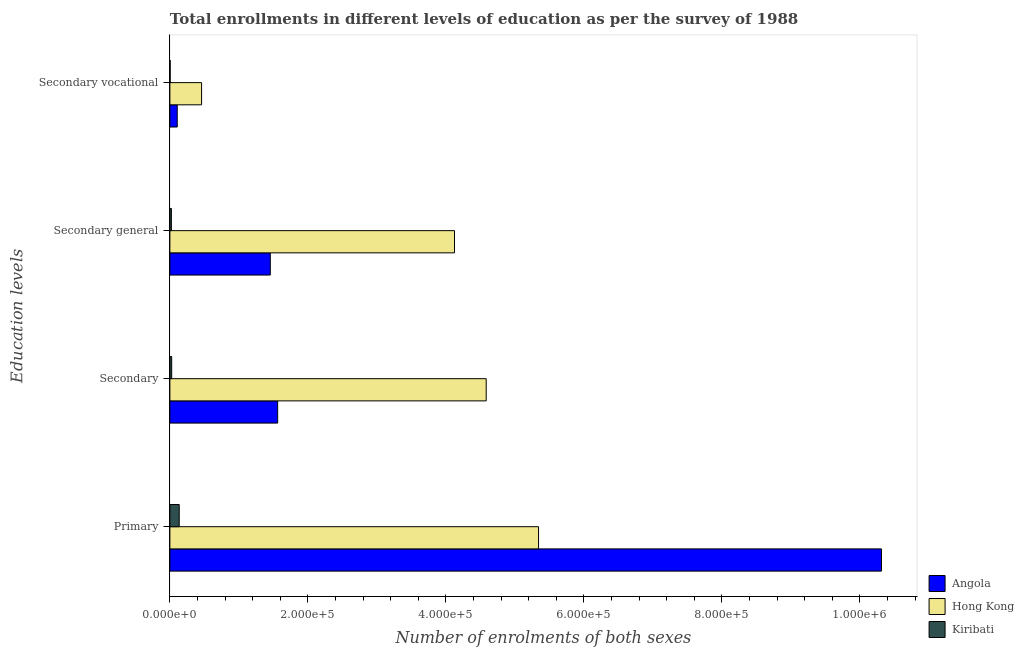How many groups of bars are there?
Offer a very short reply. 4. Are the number of bars on each tick of the Y-axis equal?
Offer a very short reply. Yes. How many bars are there on the 4th tick from the top?
Ensure brevity in your answer.  3. How many bars are there on the 4th tick from the bottom?
Your response must be concise. 3. What is the label of the 2nd group of bars from the top?
Ensure brevity in your answer.  Secondary general. What is the number of enrolments in primary education in Angola?
Ensure brevity in your answer.  1.03e+06. Across all countries, what is the maximum number of enrolments in secondary general education?
Make the answer very short. 4.13e+05. Across all countries, what is the minimum number of enrolments in secondary general education?
Offer a terse response. 2191. In which country was the number of enrolments in secondary general education maximum?
Your response must be concise. Hong Kong. In which country was the number of enrolments in secondary vocational education minimum?
Ensure brevity in your answer.  Kiribati. What is the total number of enrolments in secondary education in the graph?
Provide a succinct answer. 6.17e+05. What is the difference between the number of enrolments in secondary vocational education in Hong Kong and that in Kiribati?
Provide a short and direct response. 4.55e+04. What is the difference between the number of enrolments in primary education in Hong Kong and the number of enrolments in secondary general education in Angola?
Provide a succinct answer. 3.89e+05. What is the average number of enrolments in secondary general education per country?
Ensure brevity in your answer.  1.87e+05. What is the difference between the number of enrolments in secondary education and number of enrolments in secondary vocational education in Hong Kong?
Ensure brevity in your answer.  4.13e+05. What is the ratio of the number of enrolments in secondary vocational education in Kiribati to that in Angola?
Offer a terse response. 0.04. What is the difference between the highest and the second highest number of enrolments in primary education?
Your answer should be very brief. 4.97e+05. What is the difference between the highest and the lowest number of enrolments in secondary education?
Offer a terse response. 4.56e+05. In how many countries, is the number of enrolments in secondary general education greater than the average number of enrolments in secondary general education taken over all countries?
Ensure brevity in your answer.  1. Is the sum of the number of enrolments in secondary general education in Angola and Kiribati greater than the maximum number of enrolments in secondary vocational education across all countries?
Offer a terse response. Yes. What does the 1st bar from the top in Primary represents?
Provide a succinct answer. Kiribati. What does the 3rd bar from the bottom in Secondary vocational represents?
Your answer should be very brief. Kiribati. Is it the case that in every country, the sum of the number of enrolments in primary education and number of enrolments in secondary education is greater than the number of enrolments in secondary general education?
Your response must be concise. Yes. How many countries are there in the graph?
Provide a short and direct response. 3. What is the difference between two consecutive major ticks on the X-axis?
Provide a succinct answer. 2.00e+05. Does the graph contain any zero values?
Offer a terse response. No. Does the graph contain grids?
Ensure brevity in your answer.  No. Where does the legend appear in the graph?
Your answer should be compact. Bottom right. How many legend labels are there?
Keep it short and to the point. 3. How are the legend labels stacked?
Keep it short and to the point. Vertical. What is the title of the graph?
Provide a succinct answer. Total enrollments in different levels of education as per the survey of 1988. Does "Sudan" appear as one of the legend labels in the graph?
Provide a succinct answer. No. What is the label or title of the X-axis?
Provide a short and direct response. Number of enrolments of both sexes. What is the label or title of the Y-axis?
Offer a very short reply. Education levels. What is the Number of enrolments of both sexes in Angola in Primary?
Make the answer very short. 1.03e+06. What is the Number of enrolments of both sexes in Hong Kong in Primary?
Offer a very short reply. 5.34e+05. What is the Number of enrolments of both sexes in Kiribati in Primary?
Offer a terse response. 1.36e+04. What is the Number of enrolments of both sexes in Angola in Secondary?
Your answer should be very brief. 1.56e+05. What is the Number of enrolments of both sexes of Hong Kong in Secondary?
Provide a short and direct response. 4.58e+05. What is the Number of enrolments of both sexes of Kiribati in Secondary?
Offer a terse response. 2601. What is the Number of enrolments of both sexes in Angola in Secondary general?
Provide a short and direct response. 1.46e+05. What is the Number of enrolments of both sexes in Hong Kong in Secondary general?
Your answer should be very brief. 4.13e+05. What is the Number of enrolments of both sexes in Kiribati in Secondary general?
Your answer should be very brief. 2191. What is the Number of enrolments of both sexes of Angola in Secondary vocational?
Provide a short and direct response. 1.07e+04. What is the Number of enrolments of both sexes in Hong Kong in Secondary vocational?
Keep it short and to the point. 4.59e+04. What is the Number of enrolments of both sexes in Kiribati in Secondary vocational?
Give a very brief answer. 410. Across all Education levels, what is the maximum Number of enrolments of both sexes of Angola?
Give a very brief answer. 1.03e+06. Across all Education levels, what is the maximum Number of enrolments of both sexes of Hong Kong?
Your answer should be very brief. 5.34e+05. Across all Education levels, what is the maximum Number of enrolments of both sexes in Kiribati?
Provide a short and direct response. 1.36e+04. Across all Education levels, what is the minimum Number of enrolments of both sexes of Angola?
Ensure brevity in your answer.  1.07e+04. Across all Education levels, what is the minimum Number of enrolments of both sexes of Hong Kong?
Your answer should be very brief. 4.59e+04. Across all Education levels, what is the minimum Number of enrolments of both sexes of Kiribati?
Keep it short and to the point. 410. What is the total Number of enrolments of both sexes in Angola in the graph?
Offer a terse response. 1.34e+06. What is the total Number of enrolments of both sexes in Hong Kong in the graph?
Your response must be concise. 1.45e+06. What is the total Number of enrolments of both sexes of Kiribati in the graph?
Your response must be concise. 1.88e+04. What is the difference between the Number of enrolments of both sexes in Angola in Primary and that in Secondary?
Provide a succinct answer. 8.75e+05. What is the difference between the Number of enrolments of both sexes of Hong Kong in Primary and that in Secondary?
Ensure brevity in your answer.  7.59e+04. What is the difference between the Number of enrolments of both sexes of Kiribati in Primary and that in Secondary?
Your answer should be compact. 1.10e+04. What is the difference between the Number of enrolments of both sexes of Angola in Primary and that in Secondary general?
Offer a very short reply. 8.86e+05. What is the difference between the Number of enrolments of both sexes in Hong Kong in Primary and that in Secondary general?
Your answer should be very brief. 1.22e+05. What is the difference between the Number of enrolments of both sexes in Kiribati in Primary and that in Secondary general?
Give a very brief answer. 1.14e+04. What is the difference between the Number of enrolments of both sexes in Angola in Primary and that in Secondary vocational?
Your response must be concise. 1.02e+06. What is the difference between the Number of enrolments of both sexes of Hong Kong in Primary and that in Secondary vocational?
Provide a short and direct response. 4.88e+05. What is the difference between the Number of enrolments of both sexes of Kiribati in Primary and that in Secondary vocational?
Provide a short and direct response. 1.31e+04. What is the difference between the Number of enrolments of both sexes in Angola in Secondary and that in Secondary general?
Offer a very short reply. 1.07e+04. What is the difference between the Number of enrolments of both sexes in Hong Kong in Secondary and that in Secondary general?
Ensure brevity in your answer.  4.59e+04. What is the difference between the Number of enrolments of both sexes of Kiribati in Secondary and that in Secondary general?
Make the answer very short. 410. What is the difference between the Number of enrolments of both sexes in Angola in Secondary and that in Secondary vocational?
Offer a terse response. 1.46e+05. What is the difference between the Number of enrolments of both sexes of Hong Kong in Secondary and that in Secondary vocational?
Offer a terse response. 4.13e+05. What is the difference between the Number of enrolments of both sexes in Kiribati in Secondary and that in Secondary vocational?
Keep it short and to the point. 2191. What is the difference between the Number of enrolments of both sexes of Angola in Secondary general and that in Secondary vocational?
Offer a very short reply. 1.35e+05. What is the difference between the Number of enrolments of both sexes in Hong Kong in Secondary general and that in Secondary vocational?
Offer a terse response. 3.67e+05. What is the difference between the Number of enrolments of both sexes in Kiribati in Secondary general and that in Secondary vocational?
Ensure brevity in your answer.  1781. What is the difference between the Number of enrolments of both sexes in Angola in Primary and the Number of enrolments of both sexes in Hong Kong in Secondary?
Provide a succinct answer. 5.73e+05. What is the difference between the Number of enrolments of both sexes in Angola in Primary and the Number of enrolments of both sexes in Kiribati in Secondary?
Your answer should be compact. 1.03e+06. What is the difference between the Number of enrolments of both sexes in Hong Kong in Primary and the Number of enrolments of both sexes in Kiribati in Secondary?
Provide a succinct answer. 5.32e+05. What is the difference between the Number of enrolments of both sexes in Angola in Primary and the Number of enrolments of both sexes in Hong Kong in Secondary general?
Your answer should be compact. 6.19e+05. What is the difference between the Number of enrolments of both sexes in Angola in Primary and the Number of enrolments of both sexes in Kiribati in Secondary general?
Offer a terse response. 1.03e+06. What is the difference between the Number of enrolments of both sexes of Hong Kong in Primary and the Number of enrolments of both sexes of Kiribati in Secondary general?
Offer a very short reply. 5.32e+05. What is the difference between the Number of enrolments of both sexes of Angola in Primary and the Number of enrolments of both sexes of Hong Kong in Secondary vocational?
Ensure brevity in your answer.  9.85e+05. What is the difference between the Number of enrolments of both sexes in Angola in Primary and the Number of enrolments of both sexes in Kiribati in Secondary vocational?
Keep it short and to the point. 1.03e+06. What is the difference between the Number of enrolments of both sexes of Hong Kong in Primary and the Number of enrolments of both sexes of Kiribati in Secondary vocational?
Ensure brevity in your answer.  5.34e+05. What is the difference between the Number of enrolments of both sexes of Angola in Secondary and the Number of enrolments of both sexes of Hong Kong in Secondary general?
Provide a short and direct response. -2.56e+05. What is the difference between the Number of enrolments of both sexes of Angola in Secondary and the Number of enrolments of both sexes of Kiribati in Secondary general?
Your response must be concise. 1.54e+05. What is the difference between the Number of enrolments of both sexes in Hong Kong in Secondary and the Number of enrolments of both sexes in Kiribati in Secondary general?
Provide a succinct answer. 4.56e+05. What is the difference between the Number of enrolments of both sexes in Angola in Secondary and the Number of enrolments of both sexes in Hong Kong in Secondary vocational?
Give a very brief answer. 1.10e+05. What is the difference between the Number of enrolments of both sexes of Angola in Secondary and the Number of enrolments of both sexes of Kiribati in Secondary vocational?
Your answer should be compact. 1.56e+05. What is the difference between the Number of enrolments of both sexes in Hong Kong in Secondary and the Number of enrolments of both sexes in Kiribati in Secondary vocational?
Your answer should be compact. 4.58e+05. What is the difference between the Number of enrolments of both sexes in Angola in Secondary general and the Number of enrolments of both sexes in Hong Kong in Secondary vocational?
Give a very brief answer. 9.96e+04. What is the difference between the Number of enrolments of both sexes in Angola in Secondary general and the Number of enrolments of both sexes in Kiribati in Secondary vocational?
Provide a short and direct response. 1.45e+05. What is the difference between the Number of enrolments of both sexes of Hong Kong in Secondary general and the Number of enrolments of both sexes of Kiribati in Secondary vocational?
Keep it short and to the point. 4.12e+05. What is the average Number of enrolments of both sexes in Angola per Education levels?
Offer a very short reply. 3.36e+05. What is the average Number of enrolments of both sexes in Hong Kong per Education levels?
Your response must be concise. 3.63e+05. What is the average Number of enrolments of both sexes in Kiribati per Education levels?
Your answer should be compact. 4688.25. What is the difference between the Number of enrolments of both sexes in Angola and Number of enrolments of both sexes in Hong Kong in Primary?
Give a very brief answer. 4.97e+05. What is the difference between the Number of enrolments of both sexes in Angola and Number of enrolments of both sexes in Kiribati in Primary?
Offer a very short reply. 1.02e+06. What is the difference between the Number of enrolments of both sexes of Hong Kong and Number of enrolments of both sexes of Kiribati in Primary?
Your response must be concise. 5.21e+05. What is the difference between the Number of enrolments of both sexes of Angola and Number of enrolments of both sexes of Hong Kong in Secondary?
Your response must be concise. -3.02e+05. What is the difference between the Number of enrolments of both sexes in Angola and Number of enrolments of both sexes in Kiribati in Secondary?
Provide a short and direct response. 1.54e+05. What is the difference between the Number of enrolments of both sexes of Hong Kong and Number of enrolments of both sexes of Kiribati in Secondary?
Ensure brevity in your answer.  4.56e+05. What is the difference between the Number of enrolments of both sexes of Angola and Number of enrolments of both sexes of Hong Kong in Secondary general?
Offer a terse response. -2.67e+05. What is the difference between the Number of enrolments of both sexes in Angola and Number of enrolments of both sexes in Kiribati in Secondary general?
Provide a succinct answer. 1.43e+05. What is the difference between the Number of enrolments of both sexes in Hong Kong and Number of enrolments of both sexes in Kiribati in Secondary general?
Offer a terse response. 4.10e+05. What is the difference between the Number of enrolments of both sexes of Angola and Number of enrolments of both sexes of Hong Kong in Secondary vocational?
Your answer should be very brief. -3.53e+04. What is the difference between the Number of enrolments of both sexes of Angola and Number of enrolments of both sexes of Kiribati in Secondary vocational?
Offer a very short reply. 1.03e+04. What is the difference between the Number of enrolments of both sexes of Hong Kong and Number of enrolments of both sexes of Kiribati in Secondary vocational?
Provide a succinct answer. 4.55e+04. What is the ratio of the Number of enrolments of both sexes of Angola in Primary to that in Secondary?
Provide a short and direct response. 6.6. What is the ratio of the Number of enrolments of both sexes in Hong Kong in Primary to that in Secondary?
Your answer should be compact. 1.17. What is the ratio of the Number of enrolments of both sexes of Kiribati in Primary to that in Secondary?
Your answer should be very brief. 5.21. What is the ratio of the Number of enrolments of both sexes of Angola in Primary to that in Secondary general?
Offer a very short reply. 7.09. What is the ratio of the Number of enrolments of both sexes in Hong Kong in Primary to that in Secondary general?
Make the answer very short. 1.3. What is the ratio of the Number of enrolments of both sexes of Kiribati in Primary to that in Secondary general?
Your response must be concise. 6.18. What is the ratio of the Number of enrolments of both sexes of Angola in Primary to that in Secondary vocational?
Your response must be concise. 96.73. What is the ratio of the Number of enrolments of both sexes of Hong Kong in Primary to that in Secondary vocational?
Offer a terse response. 11.63. What is the ratio of the Number of enrolments of both sexes of Kiribati in Primary to that in Secondary vocational?
Keep it short and to the point. 33.05. What is the ratio of the Number of enrolments of both sexes of Angola in Secondary to that in Secondary general?
Your answer should be compact. 1.07. What is the ratio of the Number of enrolments of both sexes of Hong Kong in Secondary to that in Secondary general?
Your response must be concise. 1.11. What is the ratio of the Number of enrolments of both sexes of Kiribati in Secondary to that in Secondary general?
Offer a very short reply. 1.19. What is the ratio of the Number of enrolments of both sexes in Angola in Secondary to that in Secondary vocational?
Make the answer very short. 14.65. What is the ratio of the Number of enrolments of both sexes of Hong Kong in Secondary to that in Secondary vocational?
Your response must be concise. 9.98. What is the ratio of the Number of enrolments of both sexes of Kiribati in Secondary to that in Secondary vocational?
Offer a very short reply. 6.34. What is the ratio of the Number of enrolments of both sexes in Angola in Secondary general to that in Secondary vocational?
Provide a short and direct response. 13.65. What is the ratio of the Number of enrolments of both sexes in Hong Kong in Secondary general to that in Secondary vocational?
Keep it short and to the point. 8.98. What is the ratio of the Number of enrolments of both sexes of Kiribati in Secondary general to that in Secondary vocational?
Make the answer very short. 5.34. What is the difference between the highest and the second highest Number of enrolments of both sexes in Angola?
Provide a succinct answer. 8.75e+05. What is the difference between the highest and the second highest Number of enrolments of both sexes of Hong Kong?
Provide a succinct answer. 7.59e+04. What is the difference between the highest and the second highest Number of enrolments of both sexes of Kiribati?
Give a very brief answer. 1.10e+04. What is the difference between the highest and the lowest Number of enrolments of both sexes in Angola?
Give a very brief answer. 1.02e+06. What is the difference between the highest and the lowest Number of enrolments of both sexes of Hong Kong?
Give a very brief answer. 4.88e+05. What is the difference between the highest and the lowest Number of enrolments of both sexes in Kiribati?
Your answer should be compact. 1.31e+04. 